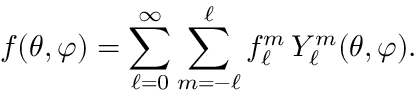<formula> <loc_0><loc_0><loc_500><loc_500>f ( \theta , \varphi ) = \sum _ { \ell = 0 } ^ { \infty } \sum _ { m = - \ell } ^ { \ell } f _ { \ell } ^ { m } \, Y _ { \ell } ^ { m } ( \theta , \varphi ) .</formula> 